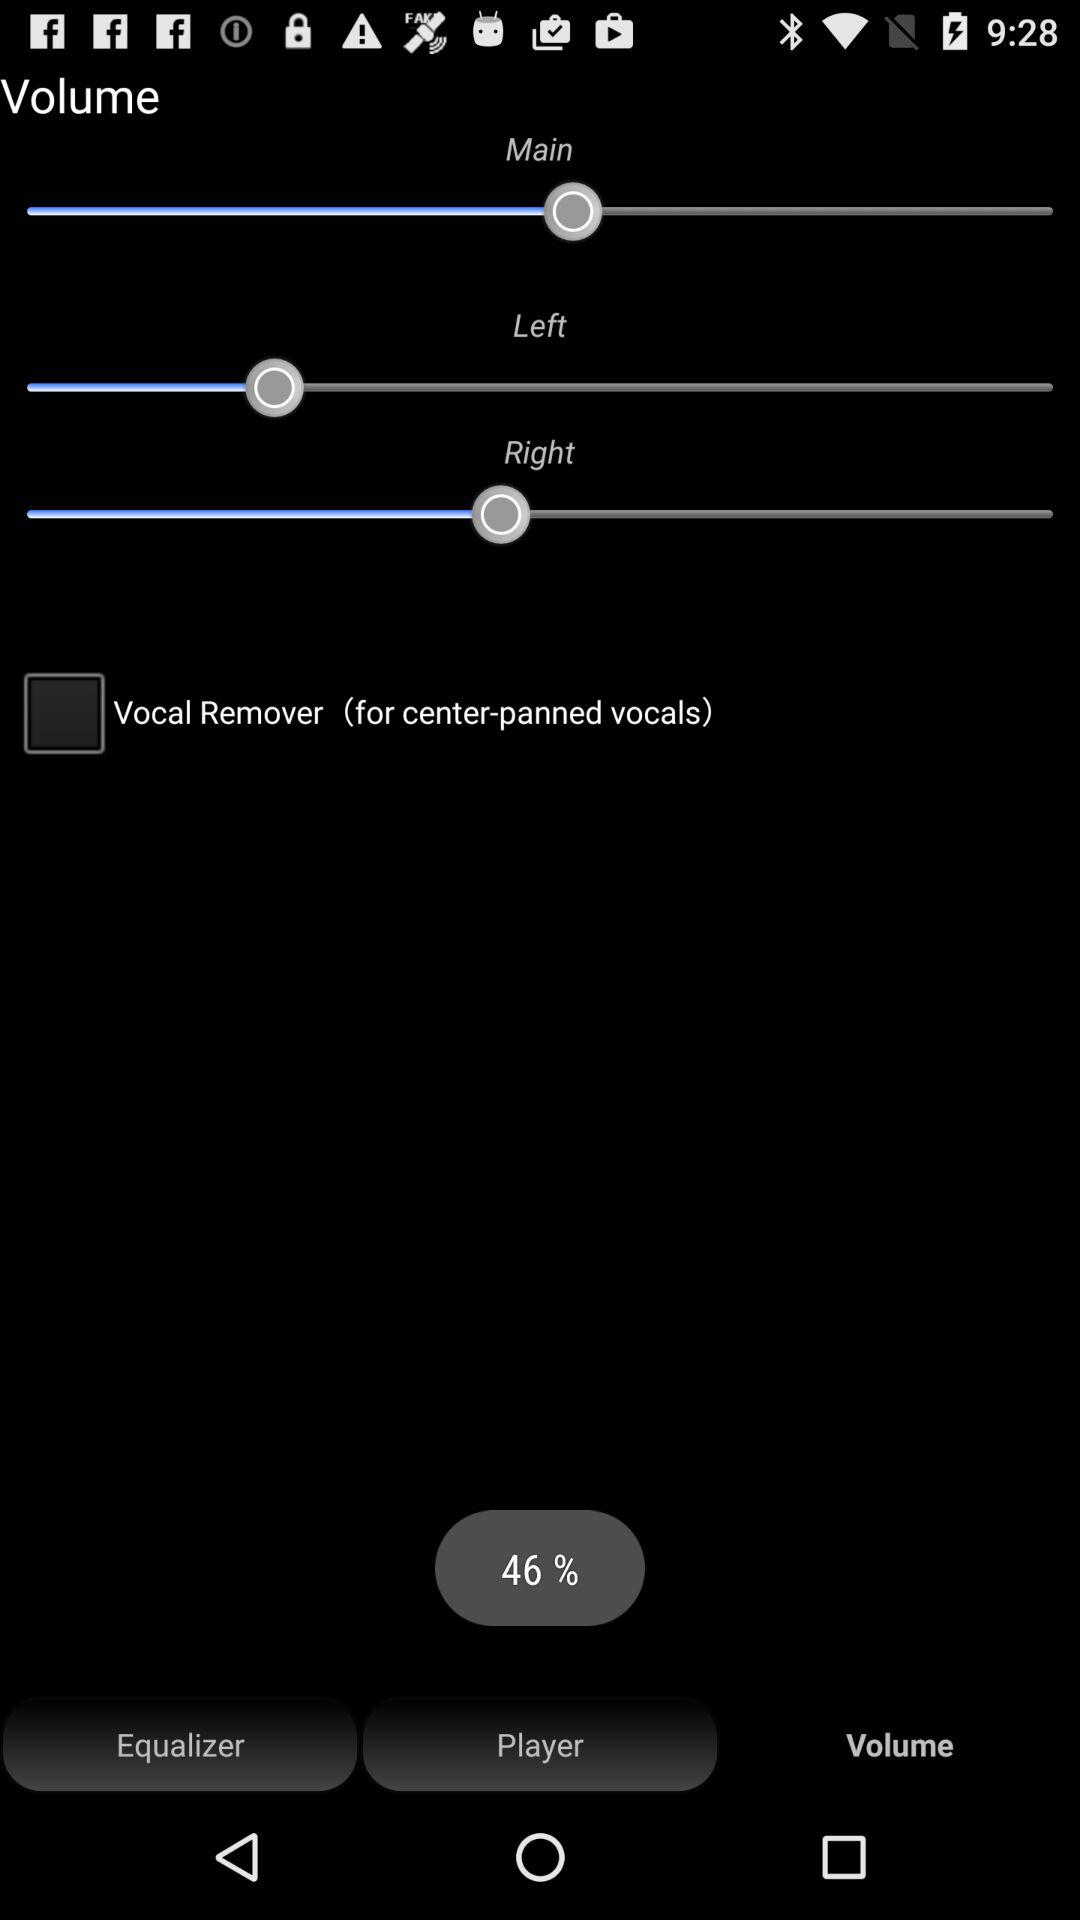What percentage is the volume set to?
Answer the question using a single word or phrase. 46% 